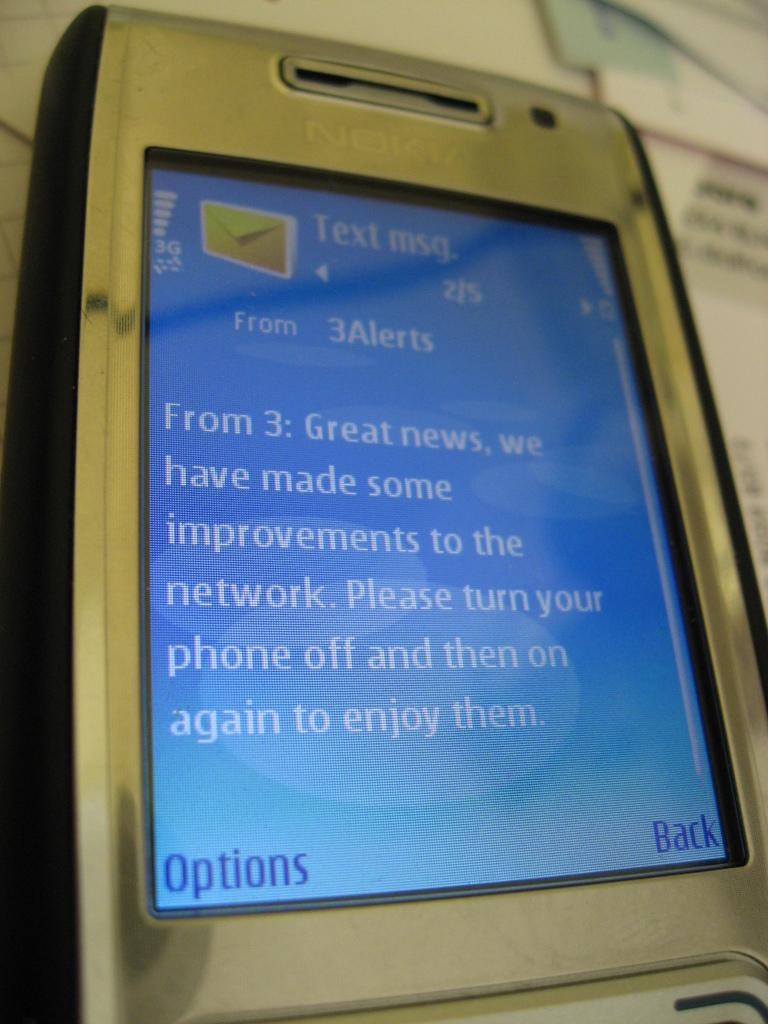<image>
Provide a brief description of the given image. A close up of a phone with the word Options in the bottom left. 